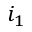<formula> <loc_0><loc_0><loc_500><loc_500>i _ { 1 }</formula> 